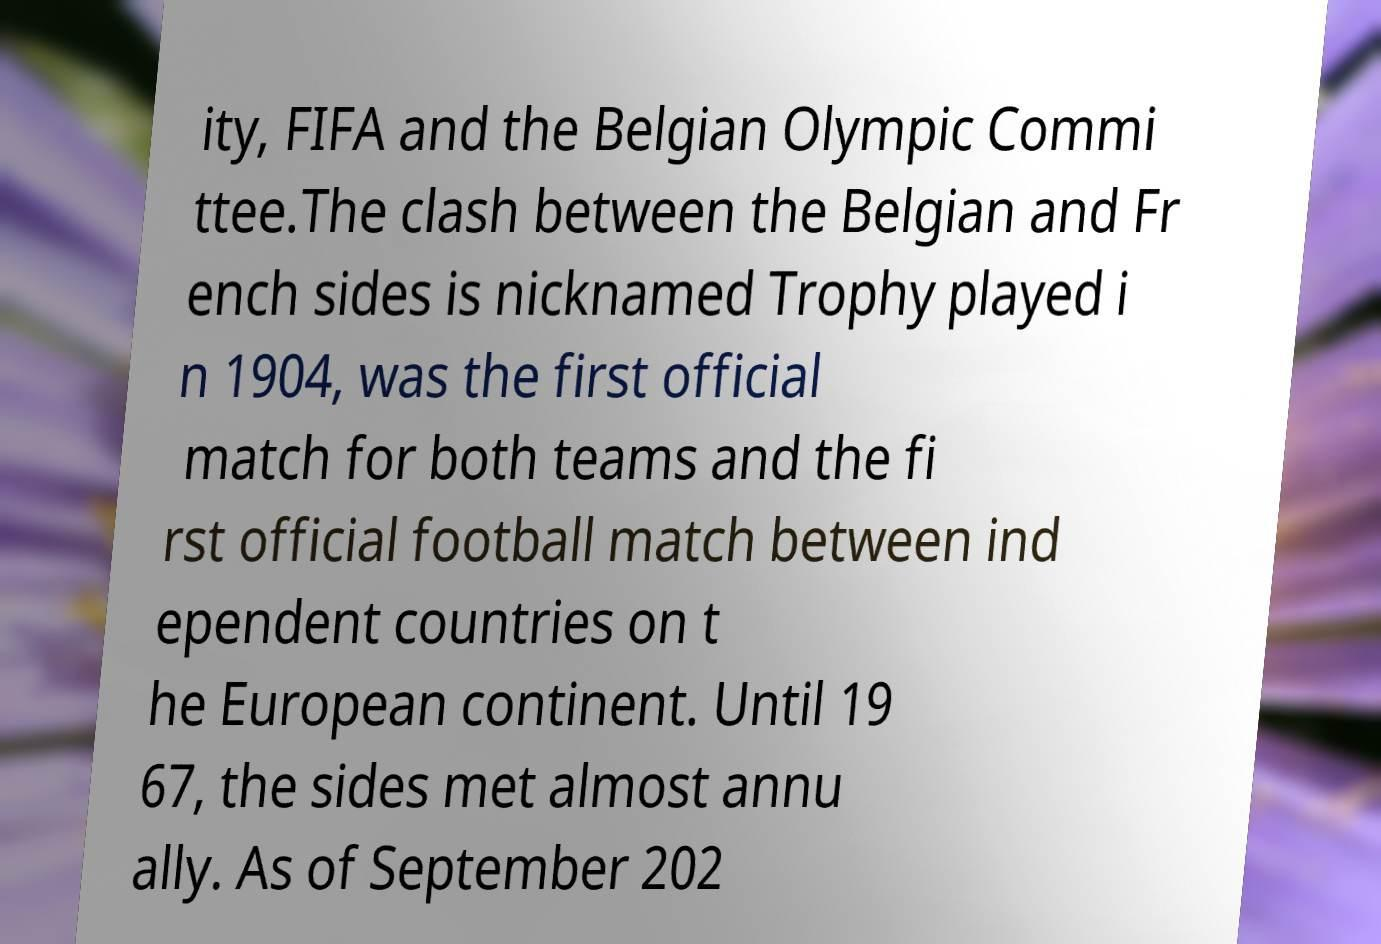Please identify and transcribe the text found in this image. ity, FIFA and the Belgian Olympic Commi ttee.The clash between the Belgian and Fr ench sides is nicknamed Trophy played i n 1904, was the first official match for both teams and the fi rst official football match between ind ependent countries on t he European continent. Until 19 67, the sides met almost annu ally. As of September 202 